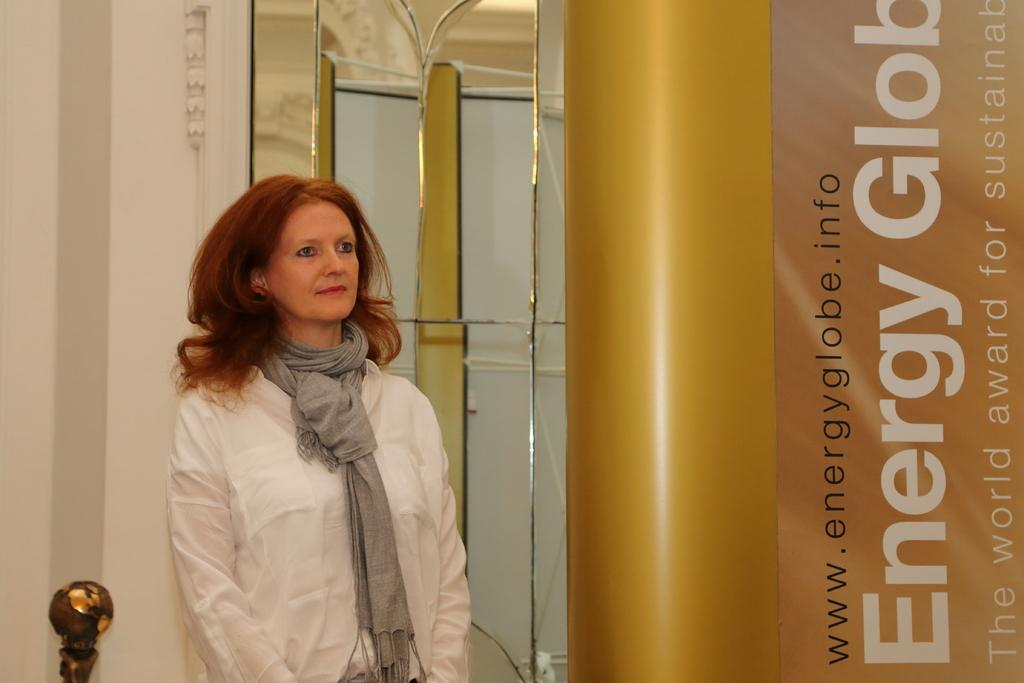Who is present in the image? There is a lady in the image. What is behind the lady? There is a mirror behind the lady. What can be seen at the rightmost part of the image? There is a banner at the rightmost part of the image. What type of apple is being used as a prop in the image? There is no apple present in the image. 